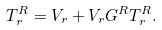Convert formula to latex. <formula><loc_0><loc_0><loc_500><loc_500>T ^ { R } _ { r } = V _ { r } + V _ { r } G ^ { R } T ^ { R } _ { r } .</formula> 